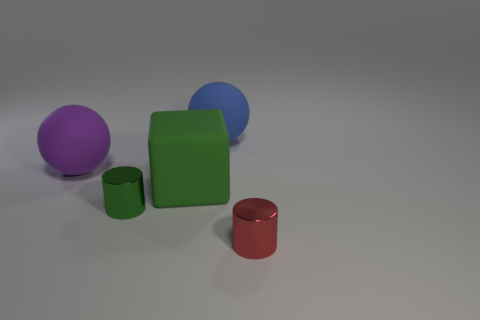Add 1 tiny green cylinders. How many objects exist? 6 Subtract all cubes. How many objects are left? 4 Subtract 1 blue spheres. How many objects are left? 4 Subtract all gray balls. Subtract all large green matte blocks. How many objects are left? 4 Add 4 blue spheres. How many blue spheres are left? 5 Add 4 red objects. How many red objects exist? 5 